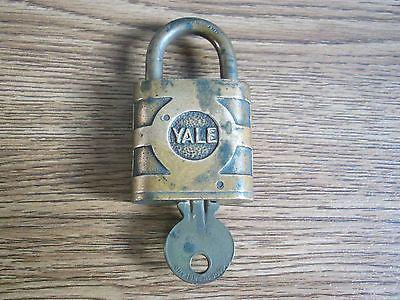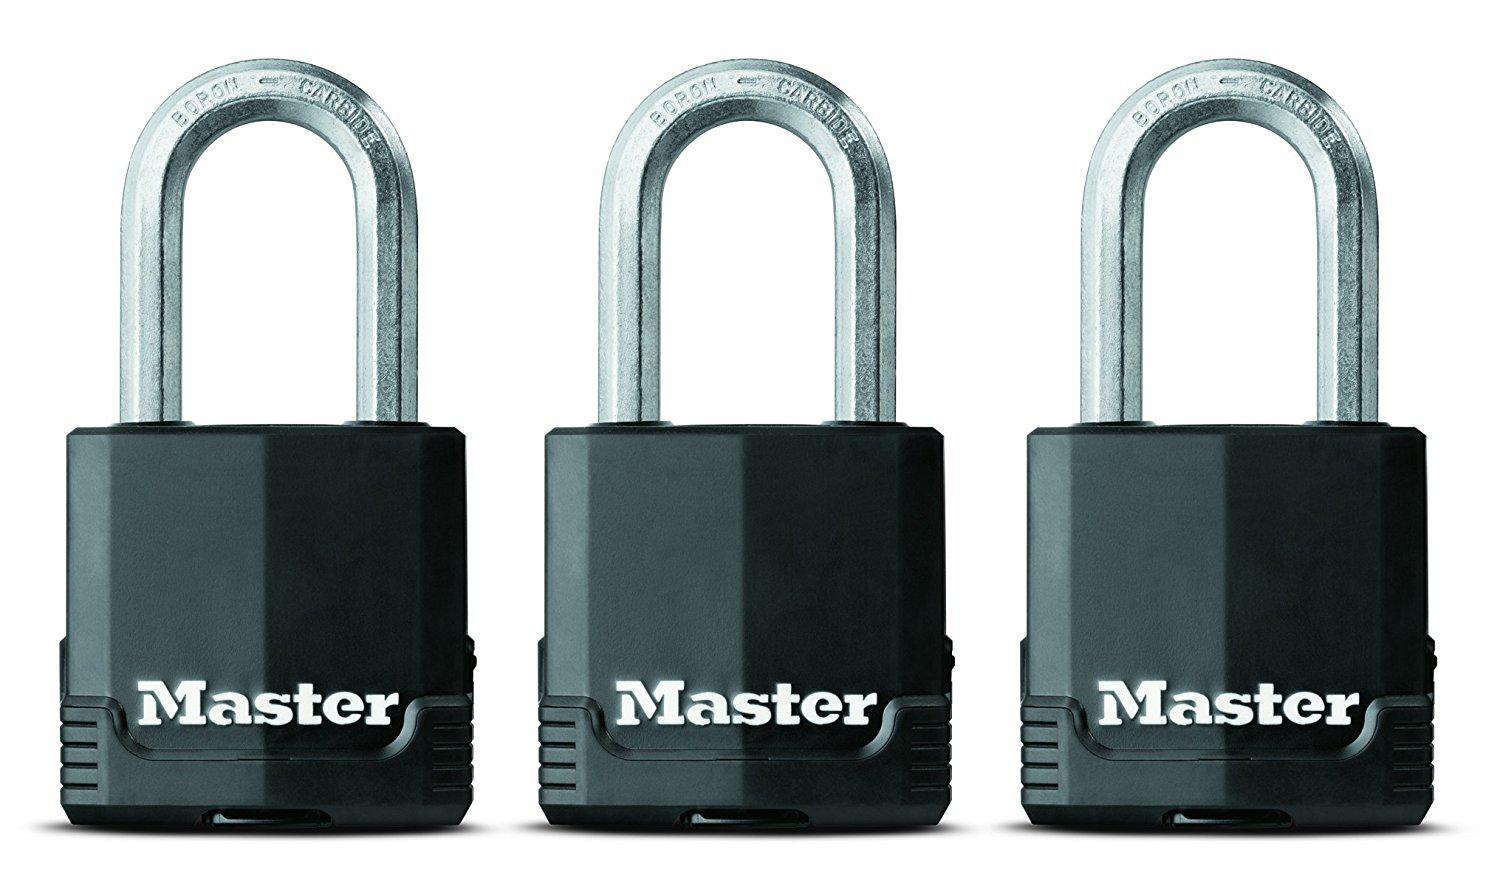The first image is the image on the left, the second image is the image on the right. For the images shown, is this caption "there are newly never opened locks in packaging" true? Answer yes or no. No. The first image is the image on the left, the second image is the image on the right. Analyze the images presented: Is the assertion "The leftmost image contains exactly 3 tarnished old locks, not brand new or in packages." valid? Answer yes or no. No. 